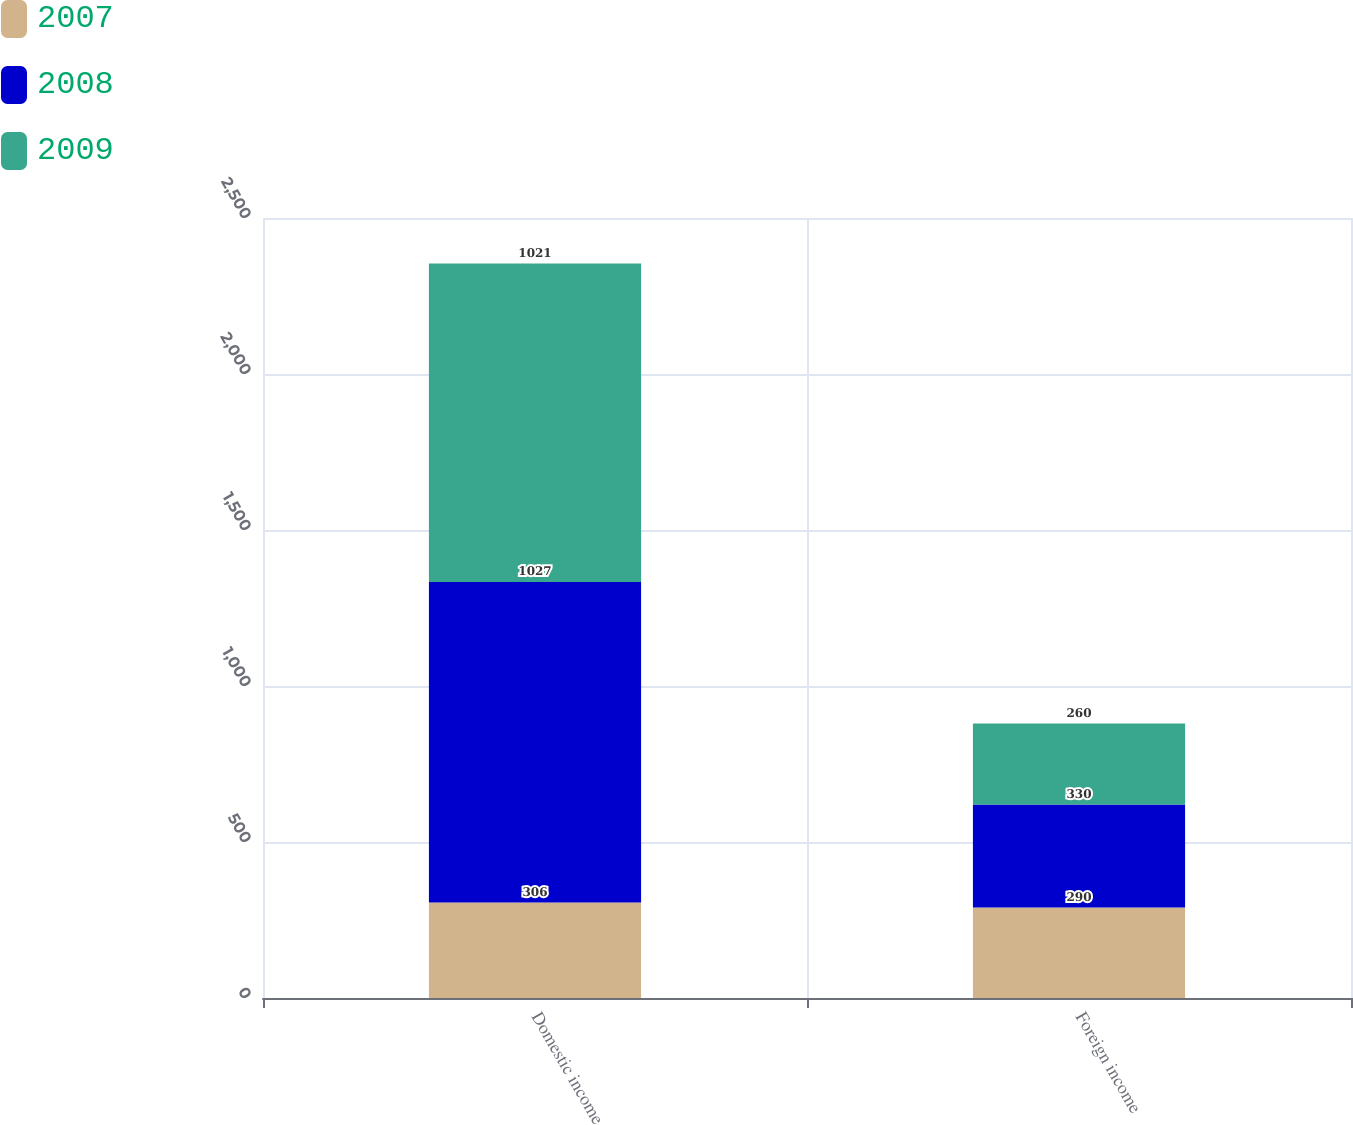Convert chart to OTSL. <chart><loc_0><loc_0><loc_500><loc_500><stacked_bar_chart><ecel><fcel>Domestic income<fcel>Foreign income<nl><fcel>2007<fcel>306<fcel>290<nl><fcel>2008<fcel>1027<fcel>330<nl><fcel>2009<fcel>1021<fcel>260<nl></chart> 